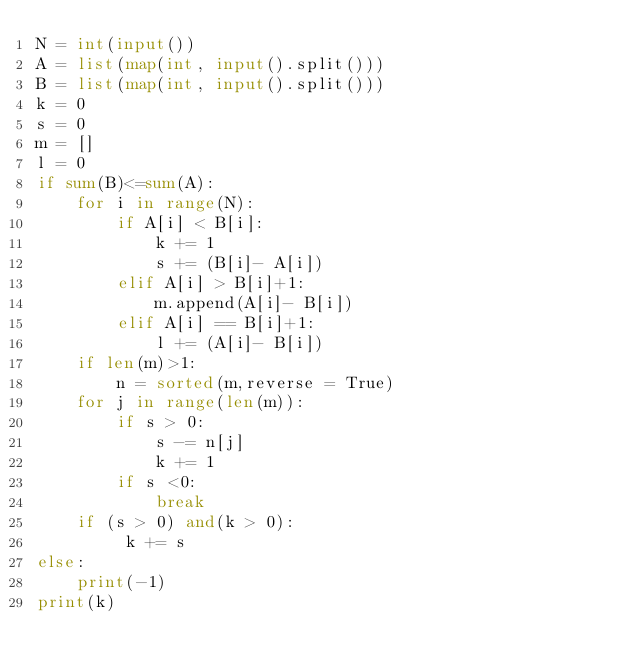Convert code to text. <code><loc_0><loc_0><loc_500><loc_500><_Python_>N = int(input())
A = list(map(int, input().split()))
B = list(map(int, input().split()))
k = 0
s = 0
m = []
l = 0
if sum(B)<=sum(A):
    for i in range(N):
        if A[i] < B[i]:
            k += 1
            s += (B[i]- A[i])
        elif A[i] > B[i]+1:
            m.append(A[i]- B[i])
        elif A[i] == B[i]+1:
            l += (A[i]- B[i])
    if len(m)>1:
        n = sorted(m,reverse = True)
    for j in range(len(m)):
        if s > 0:
            s -= n[j]
            k += 1
        if s <0:
            break
    if (s > 0) and(k > 0):
         k += s
else:
    print(-1)
print(k)</code> 